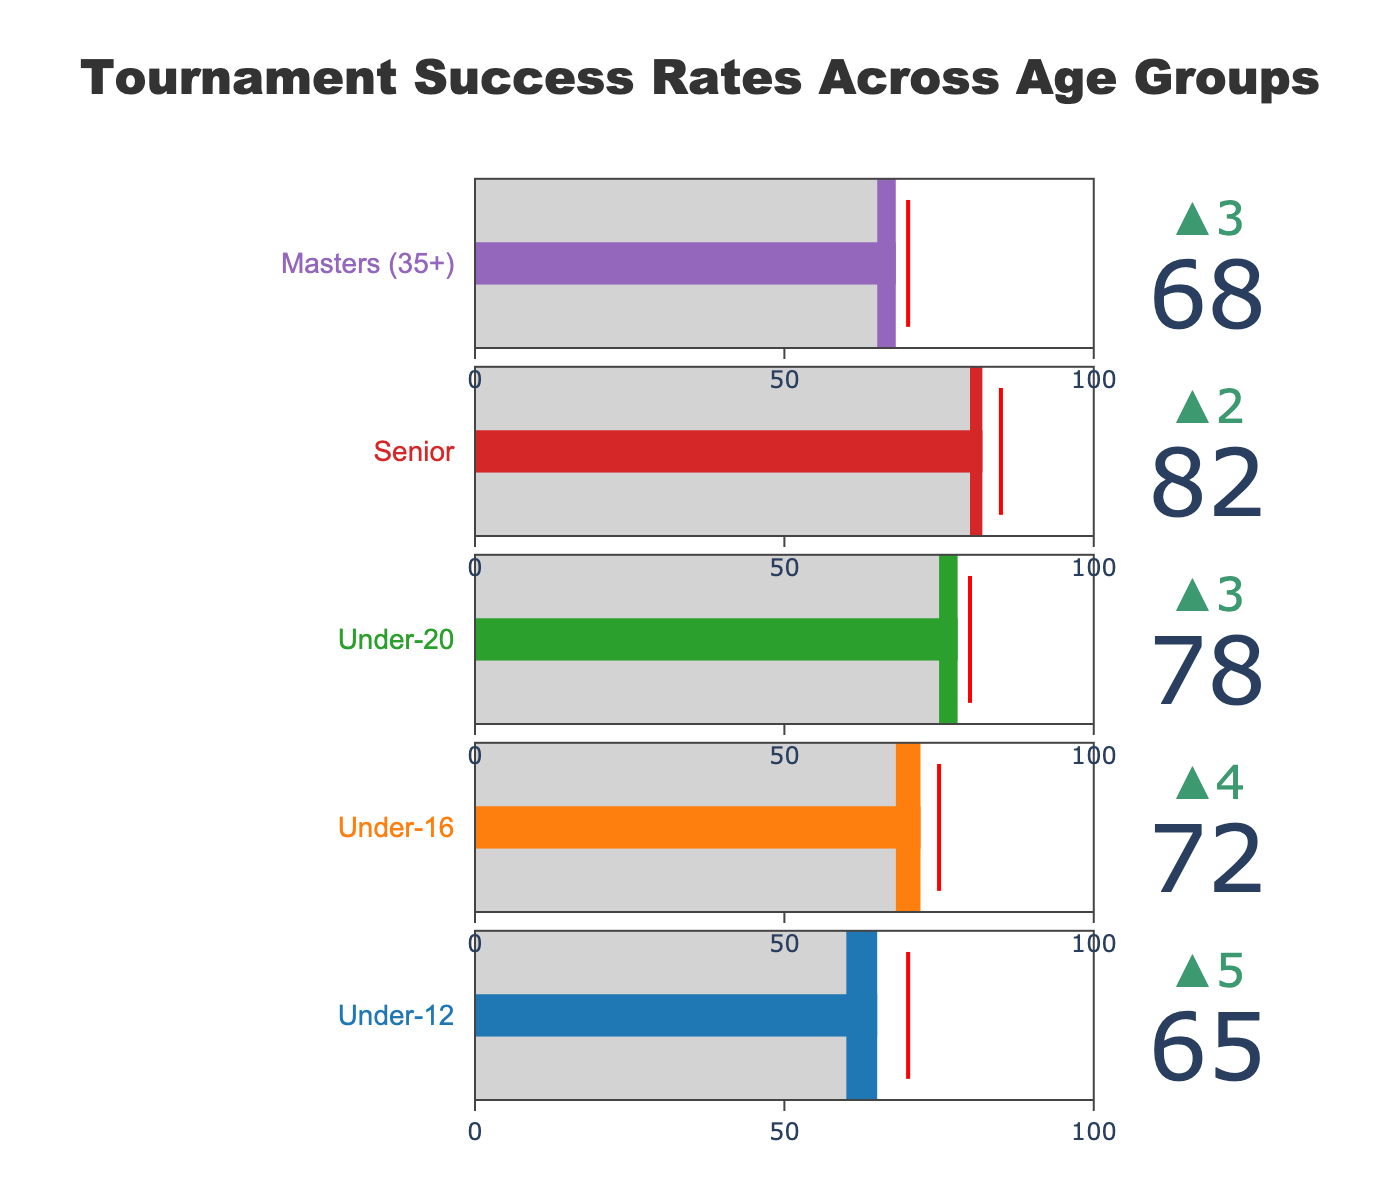What age group has the highest actual success rate? The figure shows success rates across age groups, and the Senior group has the highest actual success rate at 82%.
Answer: Senior What is the difference between the target success rate and the actual success rate for the Under-20 age group? The target success rate for the Under-20 group is 80%, and the actual success rate is 78%. The difference is 80% - 78% = 2%.
Answer: 2% Which age group has the smallest improvement from the previous year? By looking at the delta values, the Under-12 age group has an improvement of 65-60 = 5, Under-16 has 72-68 = 4, Under-20 has 78-75 = 3, Senior has 82-80 = 2, and Masters has 68-65 = 3. The smallest improvement is for the Senior age group.
Answer: Senior How far is the actual success rate for the Masters (35+) group from the maximum possible? The actual success rate for the Masters group is 68%, and the maximum possible is 100%. The difference is 100% - 68% = 32%.
Answer: 32% For which age group is the actual success rate closest to the target success rate? Comparing the actual and target success rates for each group: Under-12 (65%-70% = 5%), Under-16 (72%-75% = 3%), Under-20 (78%-80% = 2%), Senior (82%-85% = 3%), and Masters (68%-70% = 2%). The closest difference is for the Under-20 and Masters groups, both at 2%.
Answer: Under-20 and Masters What is the average actual success rate across all age groups? The actual rates are 65, 72, 78, 82, and 68 for the Under-12, Under-16, Under-20, Senior, and Masters groups, respectively. The sum is 65 + 72 + 78 + 82 + 68 = 365, and the average is 365/5 = 73.
Answer: 73 Which age group had the most significant positive change from the previous year? To determine this, calculate the difference between the actual and previous year success rates: Under-12 (65-60=5), Under-16 (72-68=4), Under-20 (78-75=3), Senior (82-80=2), Masters (68-65=3). The Under-12 group had the most significant positive change of 5 points.
Answer: Under-12 What is the total actual success rate of all age groups combined? Summing the actual success rates for all age groups: 65 + 72 + 78 + 82 + 68 = 365.
Answer: 365 Which age group fell short the most in meeting their target success rate? For each group, subtract the actual success rate from the target rate: Under-12 (70-65=5), Under-16 (75-72=3), Under-20 (80-78=2), Senior (85-82=3), and Masters (70-68=2). The Under-12 group fell short the most by 5 points.
Answer: Under-12 